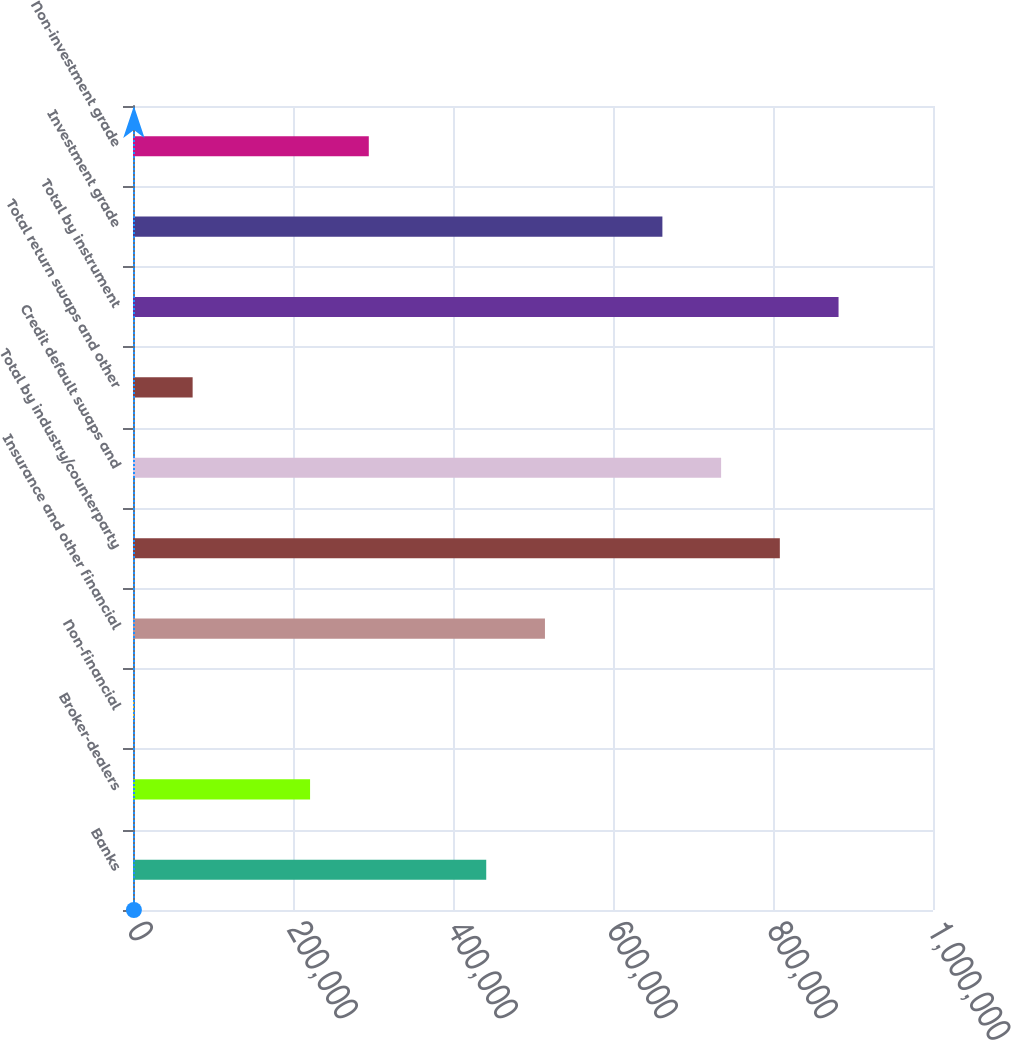<chart> <loc_0><loc_0><loc_500><loc_500><bar_chart><fcel>Banks<fcel>Broker-dealers<fcel>Non-financial<fcel>Insurance and other financial<fcel>Total by industry/counterparty<fcel>Credit default swaps and<fcel>Total return swaps and other<fcel>Total by instrument<fcel>Investment grade<fcel>Non-investment grade<nl><fcel>441541<fcel>221341<fcel>1140<fcel>514941<fcel>808542<fcel>735142<fcel>74540.2<fcel>881942<fcel>661742<fcel>294741<nl></chart> 